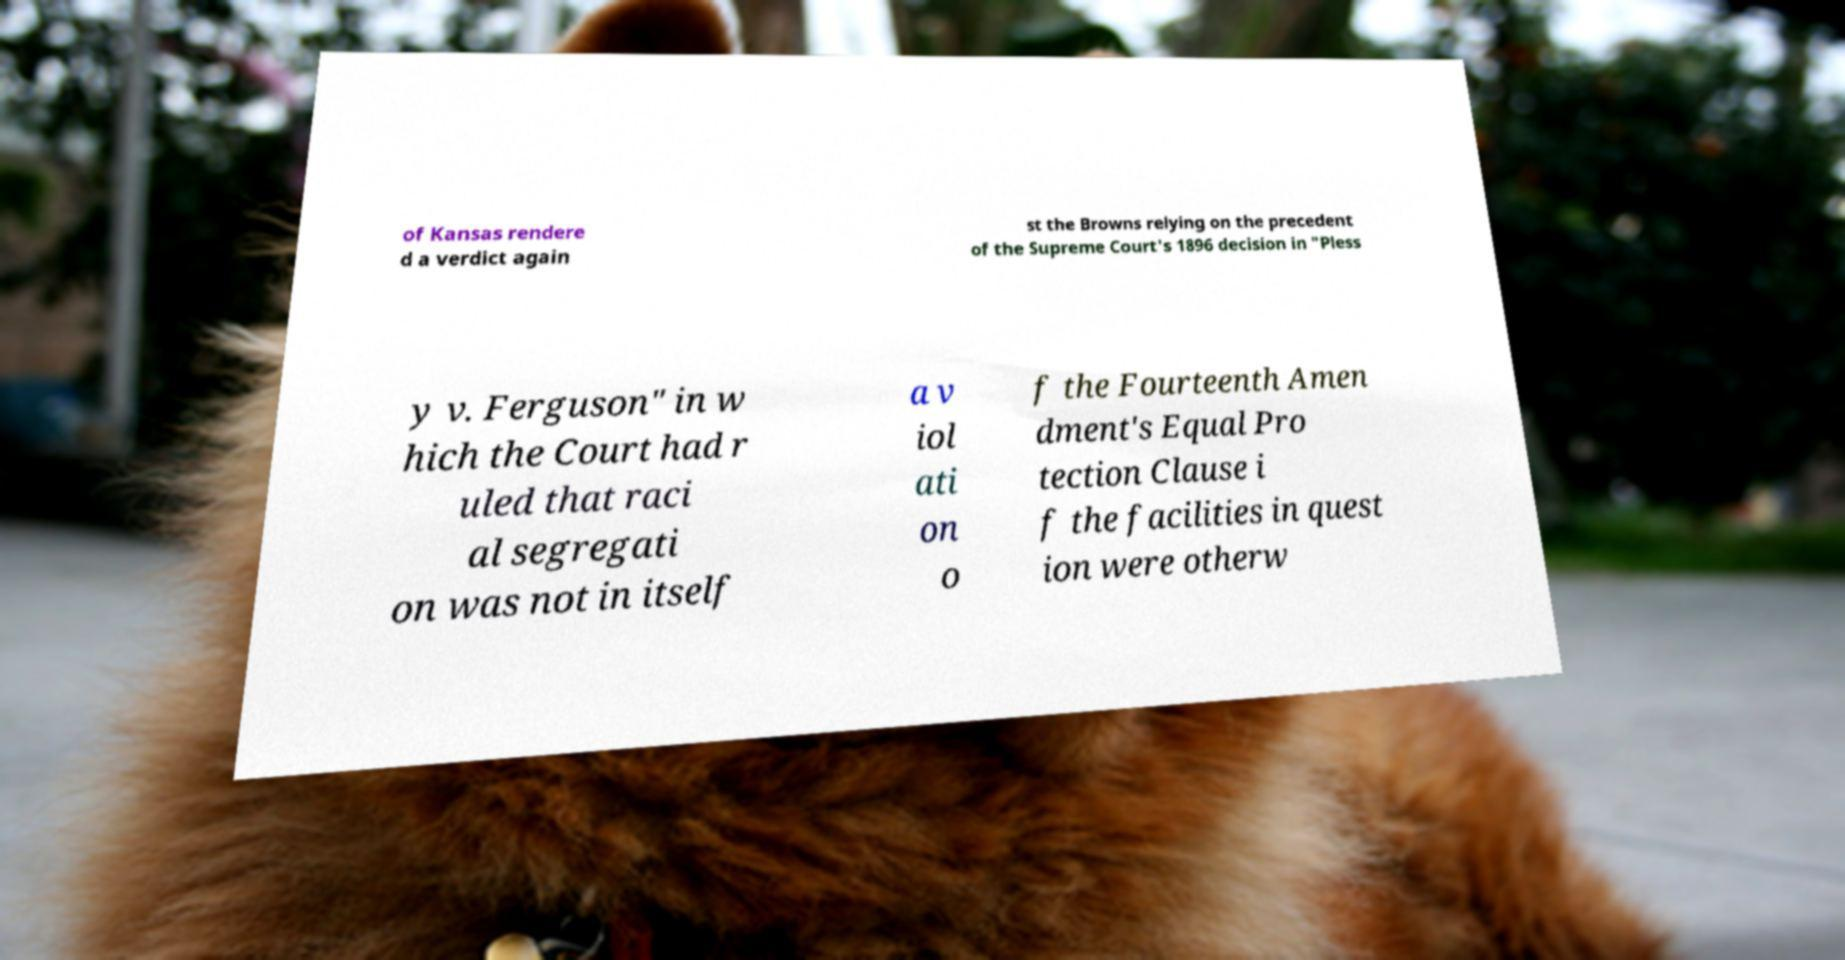Could you assist in decoding the text presented in this image and type it out clearly? of Kansas rendere d a verdict again st the Browns relying on the precedent of the Supreme Court's 1896 decision in "Pless y v. Ferguson" in w hich the Court had r uled that raci al segregati on was not in itself a v iol ati on o f the Fourteenth Amen dment's Equal Pro tection Clause i f the facilities in quest ion were otherw 